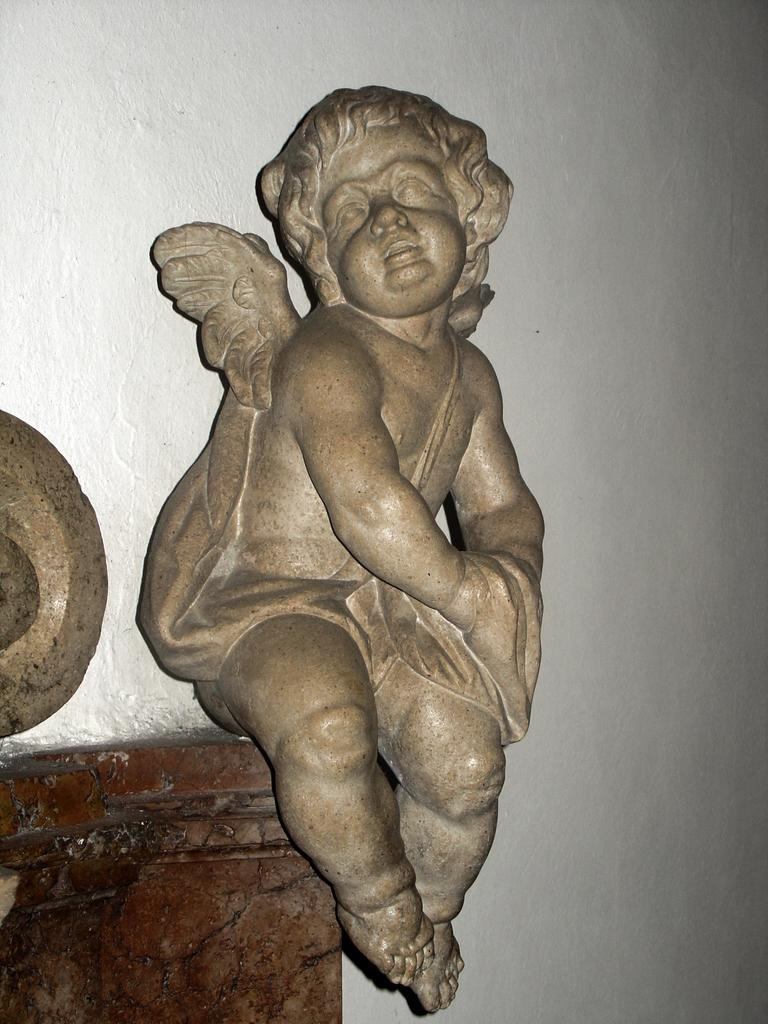What is the main subject of the image? There is a sculpture in the image. What is the sculpture placed on or near? There is an object on a wooden table in the image. What type of background can be seen in the image? There is a wall in the image. How many eggs are on the wooden table in the image? There is no mention of eggs in the image; the object on the wooden table is not specified. 